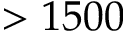Convert formula to latex. <formula><loc_0><loc_0><loc_500><loc_500>> 1 5 0 0</formula> 